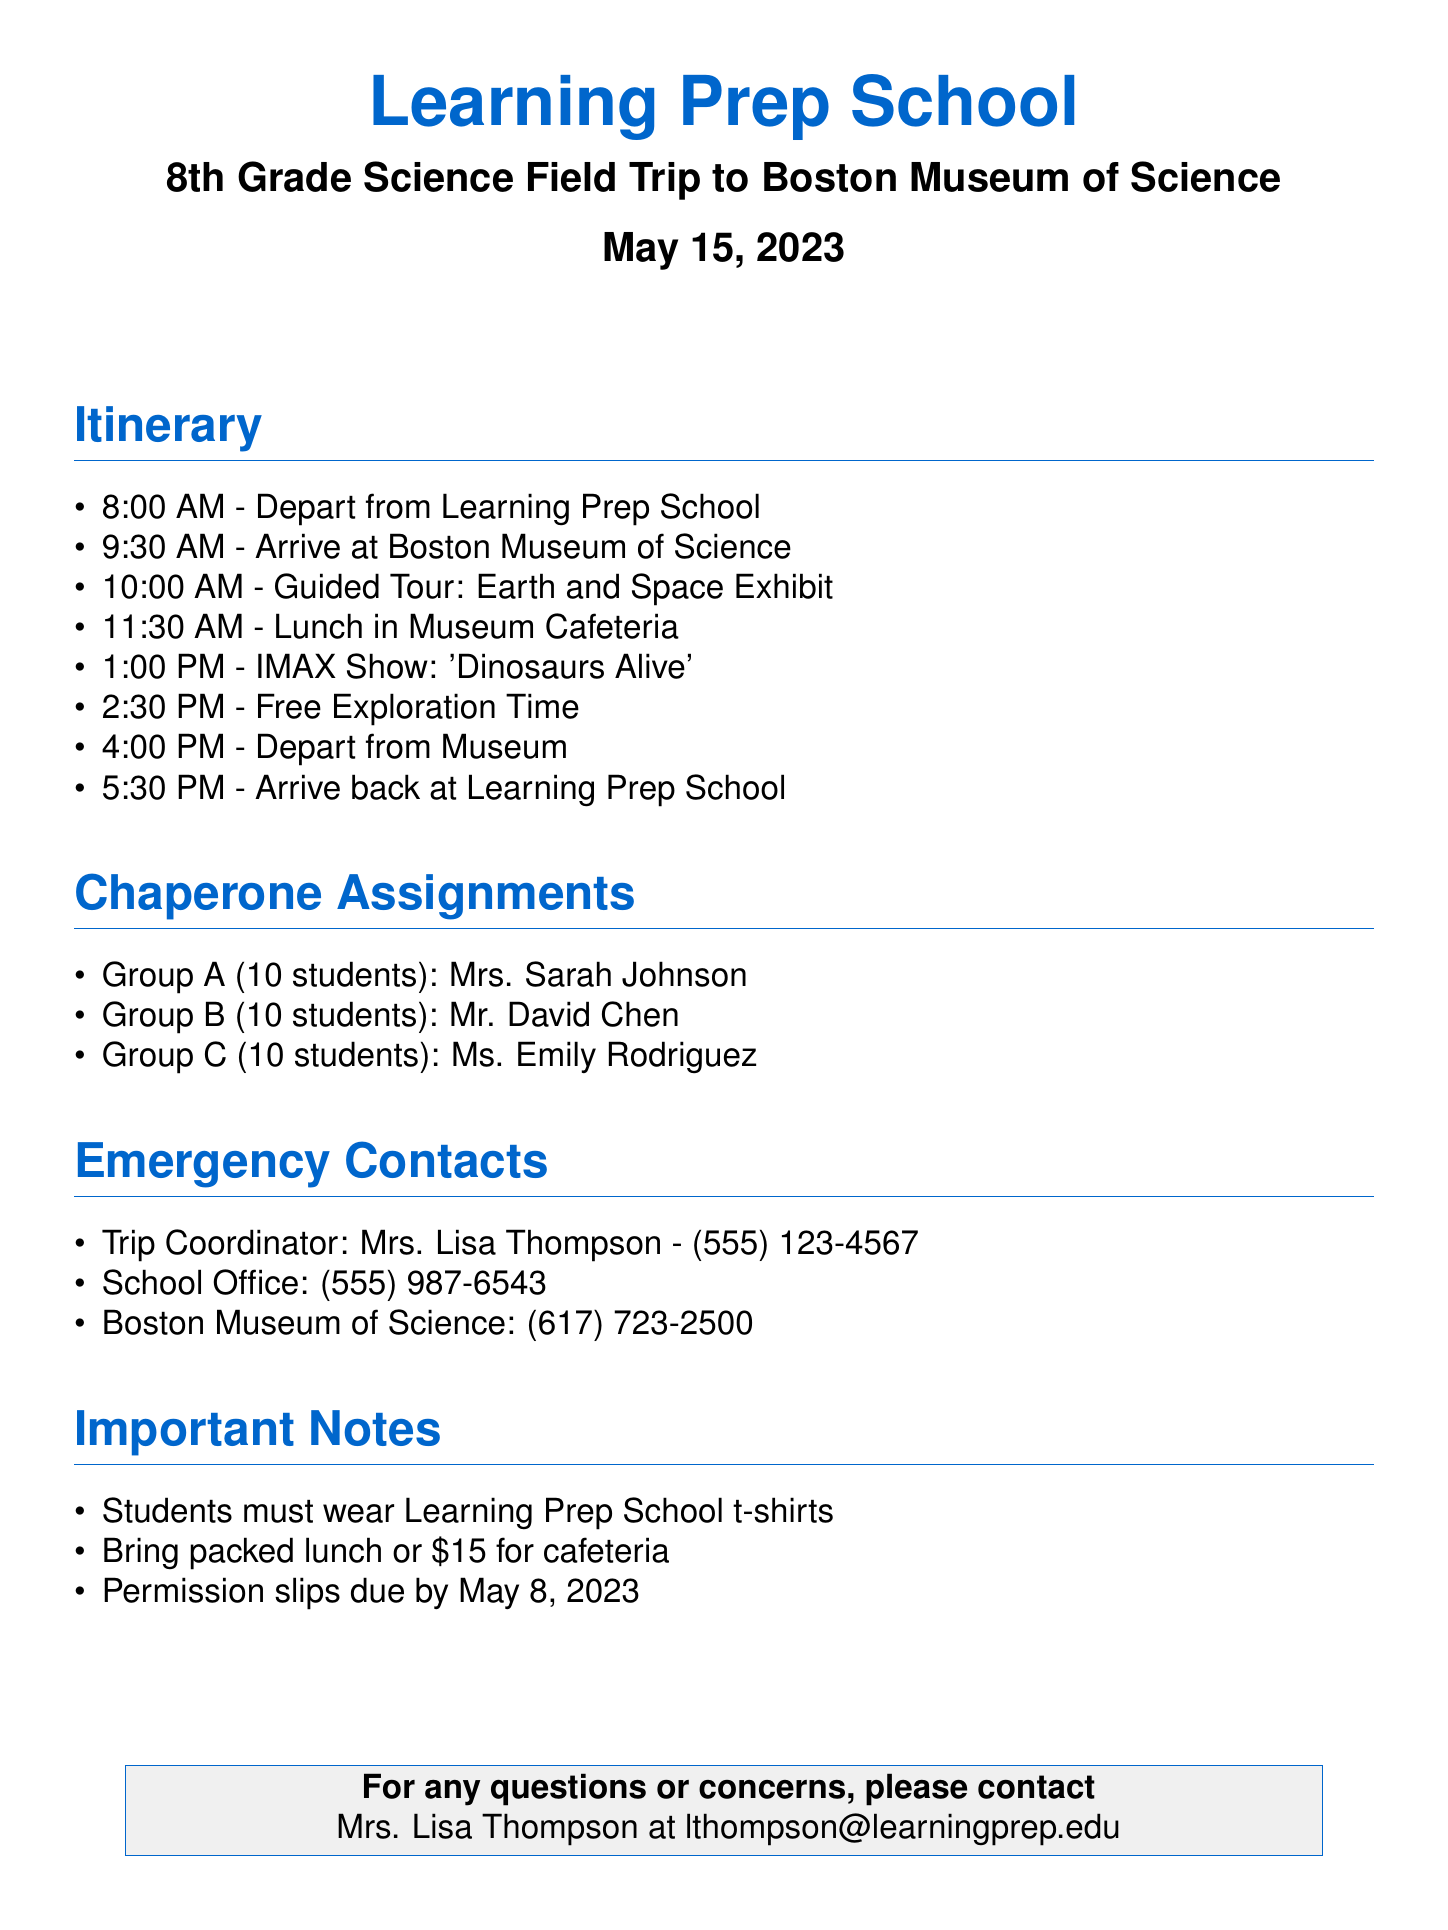What time does the trip depart? The trip departs from Learning Prep School at 8:00 AM, as listed in the itinerary section.
Answer: 8:00 AM Who is the chaperone for Group A? According to the chaperone assignments, Mrs. Sarah Johnson is assigned to Group A.
Answer: Mrs. Sarah Johnson What is the contact number for the Trip Coordinator? The document specifies Mrs. Lisa Thompson as the Trip Coordinator with the contact number (555) 123-4567.
Answer: (555) 123-4567 What should students wear on the trip? The important notes section states that students must wear Learning Prep School t-shirts.
Answer: Learning Prep School t-shirts When are permission slips due? The document indicates that permission slips are due by May 8, 2023, which is mentioned in the important notes.
Answer: May 8, 2023 What is the last activity scheduled at the museum? The itinerary outlines that the last activity scheduled is Free Exploration Time at 2:30 PM.
Answer: Free Exploration Time How many students are in each group? Each group has 10 students assigned to the chaperones, as noted in the chaperone assignments.
Answer: 10 students What time does the trip return to the school? The itinerary states the trip arrives back at Learning Prep School at 5:30 PM.
Answer: 5:30 PM 